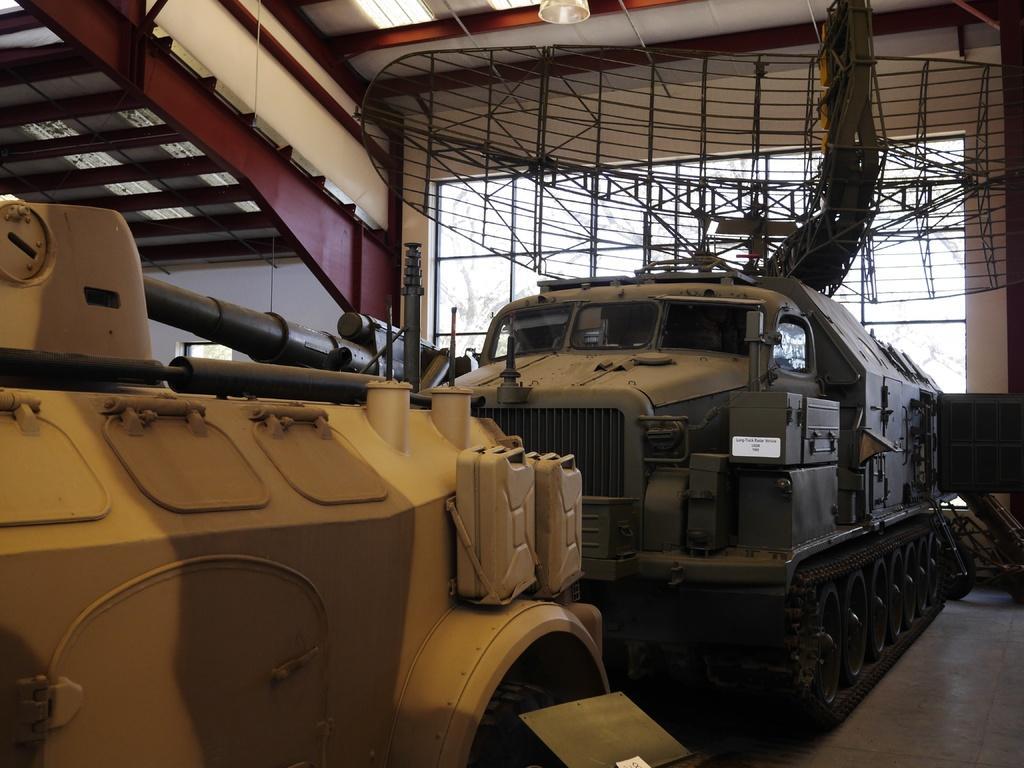Can you describe this image briefly? In this image I can see the vehicles which are in grey and yellow color. These vehicles are in the shed. I can see the red and white color roof. 